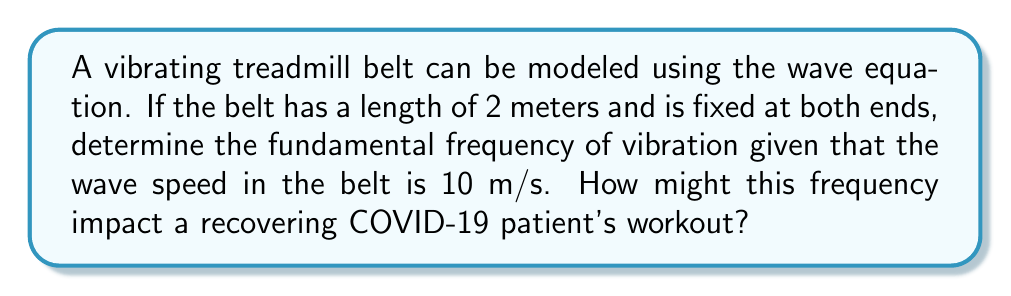Show me your answer to this math problem. Let's approach this step-by-step:

1) The wave equation for a vibrating string (which we can use to model the treadmill belt) is:

   $$\frac{\partial^2 y}{\partial t^2} = v^2 \frac{\partial^2 y}{\partial x^2}$$

   where $v$ is the wave speed.

2) For a string fixed at both ends, the general solution is:

   $$y(x,t) = \sum_{n=1}^{\infty} A_n \sin(\frac{n\pi x}{L}) \cos(\frac{n\pi v t}{L})$$

   where $L$ is the length of the string.

3) The fundamental frequency corresponds to $n=1$. The frequency $f$ is related to the angular frequency $\omega$ by:

   $$f = \frac{\omega}{2\pi}$$

4) From the general solution, we can see that:

   $$\omega = \frac{\pi v}{L}$$

5) Substituting the given values:
   $L = 2$ m
   $v = 10$ m/s

   $$f = \frac{\omega}{2\pi} = \frac{\pi v}{2\pi L} = \frac{v}{2L} = \frac{10}{2(2)} = 2.5 \text{ Hz}$$

6) This frequency of 2.5 Hz (or 150 vibrations per minute) could potentially impact a recovering COVID-19 patient in several ways:
   - It might cause additional fatigue due to the constant vibration.
   - It could affect breathing patterns, which might be challenging for someone recovering from respiratory issues.
   - The vibration might exacerbate any lingering muscle weakness or joint pain.

Therefore, a recovering patient might need to start with shorter sessions or lower speeds to accommodate these potential effects.
Answer: 2.5 Hz 